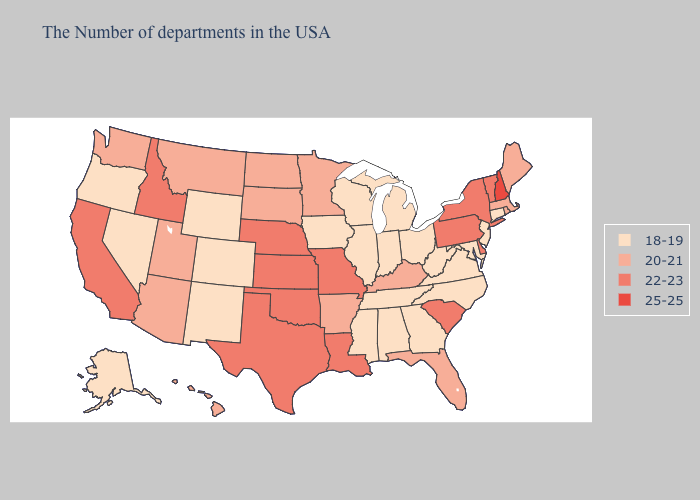Among the states that border Indiana , does Kentucky have the highest value?
Give a very brief answer. Yes. Among the states that border Vermont , does New York have the lowest value?
Answer briefly. No. Does Montana have the lowest value in the West?
Quick response, please. No. How many symbols are there in the legend?
Short answer required. 4. What is the value of Ohio?
Answer briefly. 18-19. What is the value of Washington?
Answer briefly. 20-21. Among the states that border Idaho , which have the highest value?
Answer briefly. Utah, Montana, Washington. Does Nebraska have the highest value in the MidWest?
Answer briefly. Yes. Does Tennessee have the lowest value in the South?
Be succinct. Yes. Does New Mexico have the lowest value in the USA?
Give a very brief answer. Yes. Name the states that have a value in the range 20-21?
Short answer required. Maine, Massachusetts, Rhode Island, Florida, Kentucky, Arkansas, Minnesota, South Dakota, North Dakota, Utah, Montana, Arizona, Washington, Hawaii. What is the value of New Mexico?
Answer briefly. 18-19. What is the lowest value in the USA?
Be succinct. 18-19. Which states hav the highest value in the MidWest?
Keep it brief. Missouri, Kansas, Nebraska. What is the value of Iowa?
Write a very short answer. 18-19. 